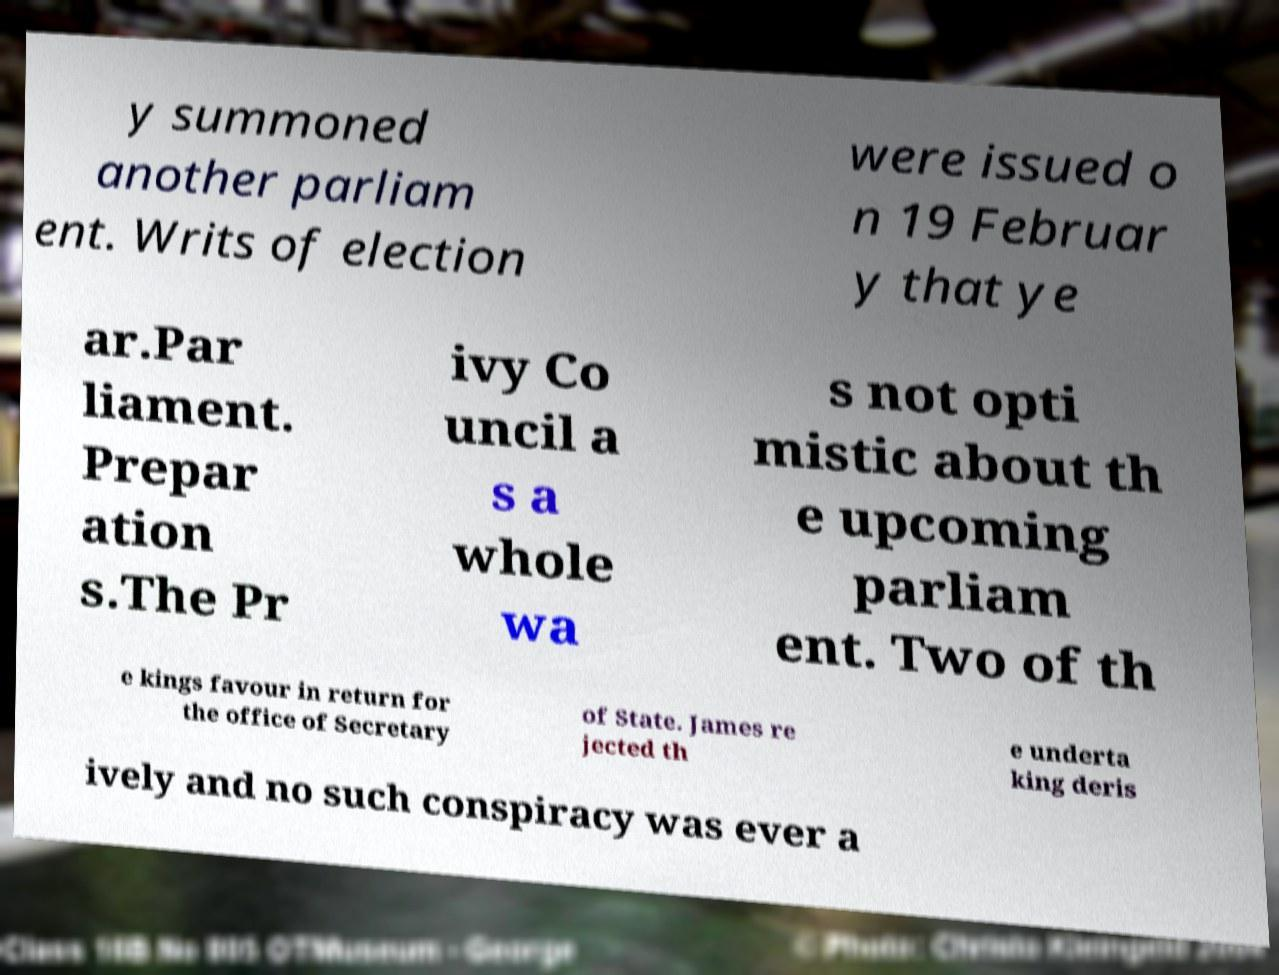Could you extract and type out the text from this image? y summoned another parliam ent. Writs of election were issued o n 19 Februar y that ye ar.Par liament. Prepar ation s.The Pr ivy Co uncil a s a whole wa s not opti mistic about th e upcoming parliam ent. Two of th e kings favour in return for the office of Secretary of State. James re jected th e underta king deris ively and no such conspiracy was ever a 